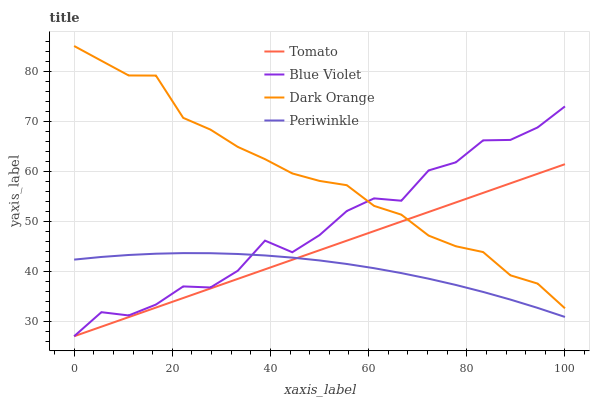Does Periwinkle have the minimum area under the curve?
Answer yes or no. Yes. Does Dark Orange have the maximum area under the curve?
Answer yes or no. Yes. Does Dark Orange have the minimum area under the curve?
Answer yes or no. No. Does Periwinkle have the maximum area under the curve?
Answer yes or no. No. Is Tomato the smoothest?
Answer yes or no. Yes. Is Blue Violet the roughest?
Answer yes or no. Yes. Is Dark Orange the smoothest?
Answer yes or no. No. Is Dark Orange the roughest?
Answer yes or no. No. Does Tomato have the lowest value?
Answer yes or no. Yes. Does Periwinkle have the lowest value?
Answer yes or no. No. Does Dark Orange have the highest value?
Answer yes or no. Yes. Does Periwinkle have the highest value?
Answer yes or no. No. Is Periwinkle less than Dark Orange?
Answer yes or no. Yes. Is Dark Orange greater than Periwinkle?
Answer yes or no. Yes. Does Tomato intersect Periwinkle?
Answer yes or no. Yes. Is Tomato less than Periwinkle?
Answer yes or no. No. Is Tomato greater than Periwinkle?
Answer yes or no. No. Does Periwinkle intersect Dark Orange?
Answer yes or no. No. 